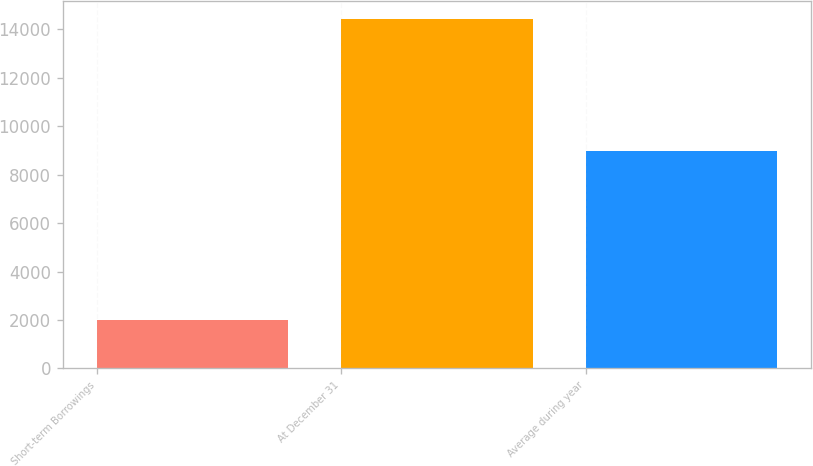Convert chart. <chart><loc_0><loc_0><loc_500><loc_500><bar_chart><fcel>Short-term Borrowings<fcel>At December 31<fcel>Average during year<nl><fcel>2008<fcel>14432<fcel>8969<nl></chart> 